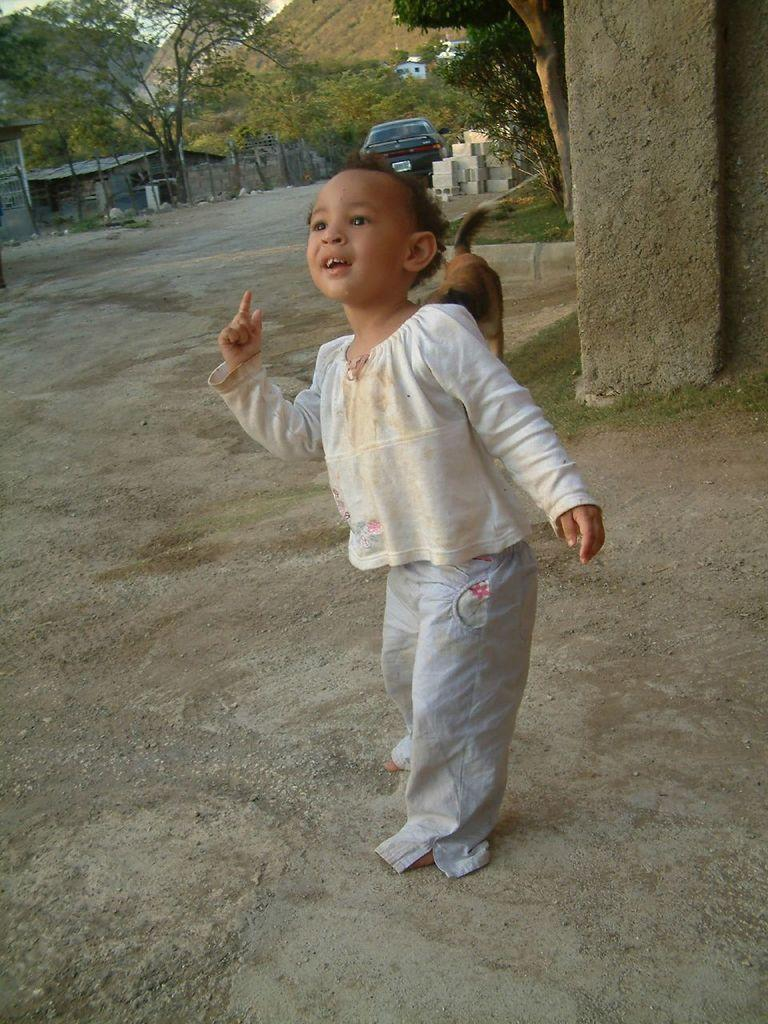What is the main subject of the image? The main subject of the image is a little kid. Where is the kid positioned in the image? The kid is standing on the ground. What is the kid doing in the image? The kid is looking at someone. What color is the ink on the thread in the image? There is no ink or thread present in the image; it features a little kid standing on the ground and looking at someone. 